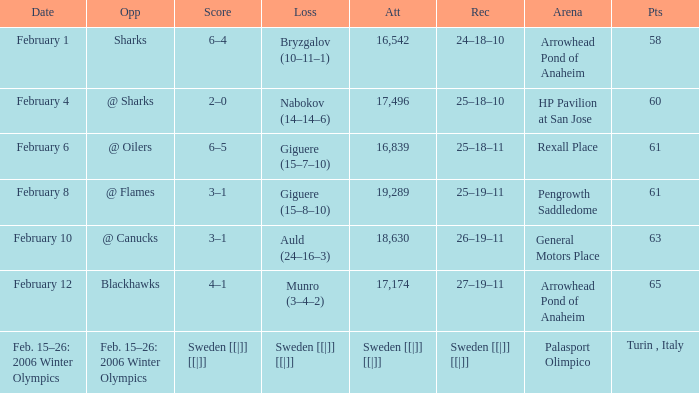What is the Arena when there were 65 points? Arrowhead Pond of Anaheim. 